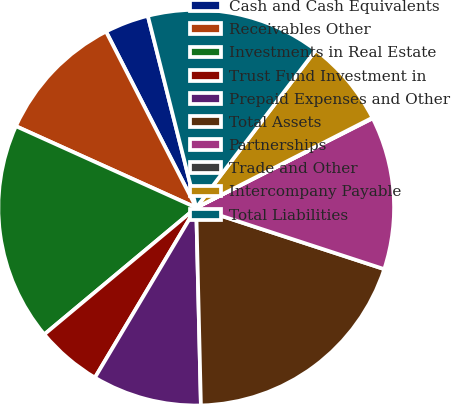<chart> <loc_0><loc_0><loc_500><loc_500><pie_chart><fcel>Cash and Cash Equivalents<fcel>Receivables Other<fcel>Investments in Real Estate<fcel>Trust Fund Investment in<fcel>Prepaid Expenses and Other<fcel>Total Assets<fcel>Partnerships<fcel>Trade and Other<fcel>Intercompany Payable<fcel>Total Liabilities<nl><fcel>3.6%<fcel>10.71%<fcel>17.82%<fcel>5.38%<fcel>8.93%<fcel>19.59%<fcel>12.49%<fcel>0.05%<fcel>7.16%<fcel>14.26%<nl></chart> 